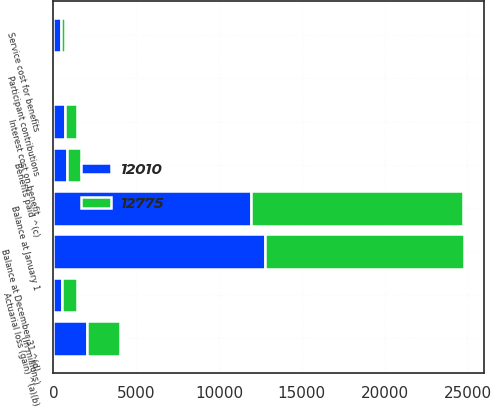Convert chart to OTSL. <chart><loc_0><loc_0><loc_500><loc_500><stacked_bar_chart><ecel><fcel>(In millions)<fcel>Balance at January 1<fcel>Service cost for benefits<fcel>Interest cost on benefit<fcel>Participant contributions<fcel>Actuarial loss (gain) ^(a)(b)<fcel>Benefits paid ^(c)<fcel>Balance at December 31 ^(d)<nl><fcel>12775<fcel>2010<fcel>12775<fcel>241<fcel>699<fcel>55<fcel>942<fcel>818<fcel>12010<nl><fcel>12010<fcel>2009<fcel>11949<fcel>442<fcel>709<fcel>50<fcel>504<fcel>842<fcel>12775<nl></chart> 